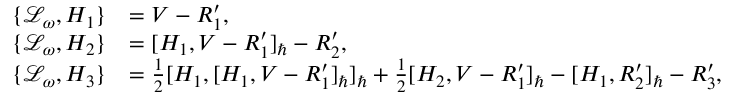Convert formula to latex. <formula><loc_0><loc_0><loc_500><loc_500>\begin{array} { r l } { \{ \mathcal { L } _ { \omega } , H _ { 1 } \} } & { = V - R _ { 1 } ^ { \prime } , } \\ { \{ \mathcal { L } _ { \omega } , H _ { 2 } \} } & { = [ H _ { 1 } , V - R _ { 1 } ^ { \prime } ] _ { } - R _ { 2 } ^ { \prime } , } \\ { \{ \mathcal { L } _ { \omega } , H _ { 3 } \} } & { = \frac { 1 } { 2 } [ H _ { 1 } , [ H _ { 1 } , V - R _ { 1 } ^ { \prime } ] _ { } ] _ { } + \frac { 1 } { 2 } [ H _ { 2 } , V - R _ { 1 } ^ { \prime } ] _ { } - [ H _ { 1 } , R _ { 2 } ^ { \prime } ] _ { } - R _ { 3 } ^ { \prime } , } \end{array}</formula> 